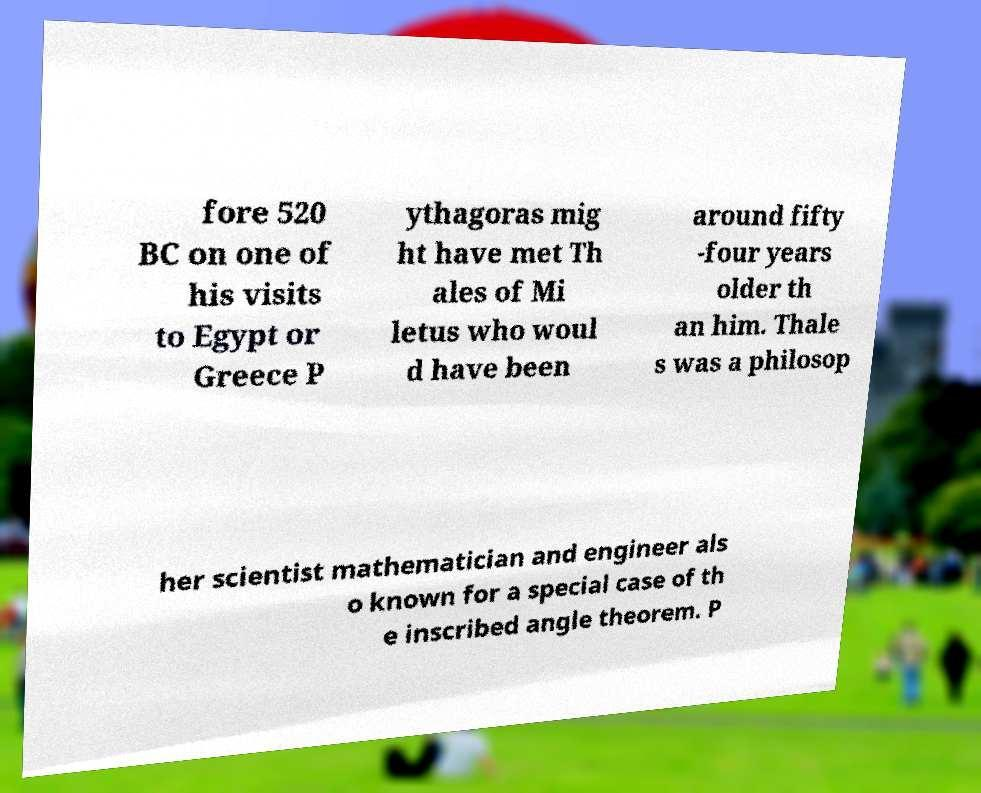I need the written content from this picture converted into text. Can you do that? fore 520 BC on one of his visits to Egypt or Greece P ythagoras mig ht have met Th ales of Mi letus who woul d have been around fifty -four years older th an him. Thale s was a philosop her scientist mathematician and engineer als o known for a special case of th e inscribed angle theorem. P 